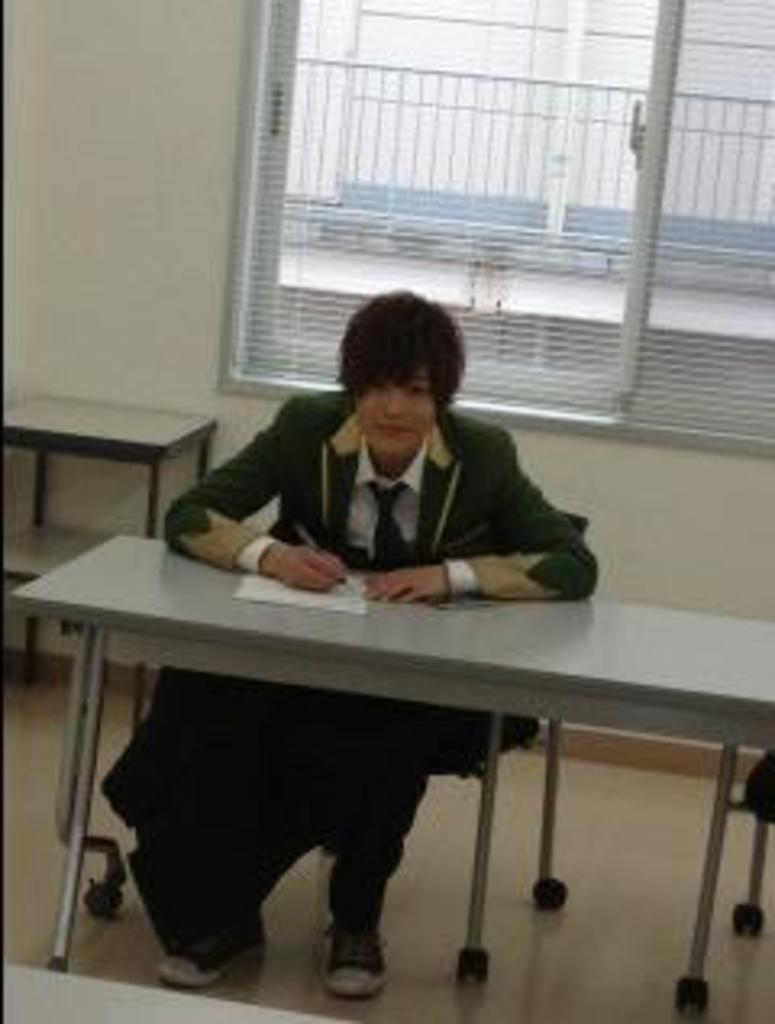What is the person in the image doing? The person is sitting on a chair and writing on a paper. What is the person using to write? The person is using a pen or pencil to write on the paper. What is the location of the person in the image? The person is sitting at a table in the image. What can be seen through the window in the image? The view through the window is not visible in the image. What is the background of the image? The background of the image includes a wall. What is the best route to take to reach the person's nose in the image? There is no nose visible in the image, so it is not possible to determine a route to reach it. 